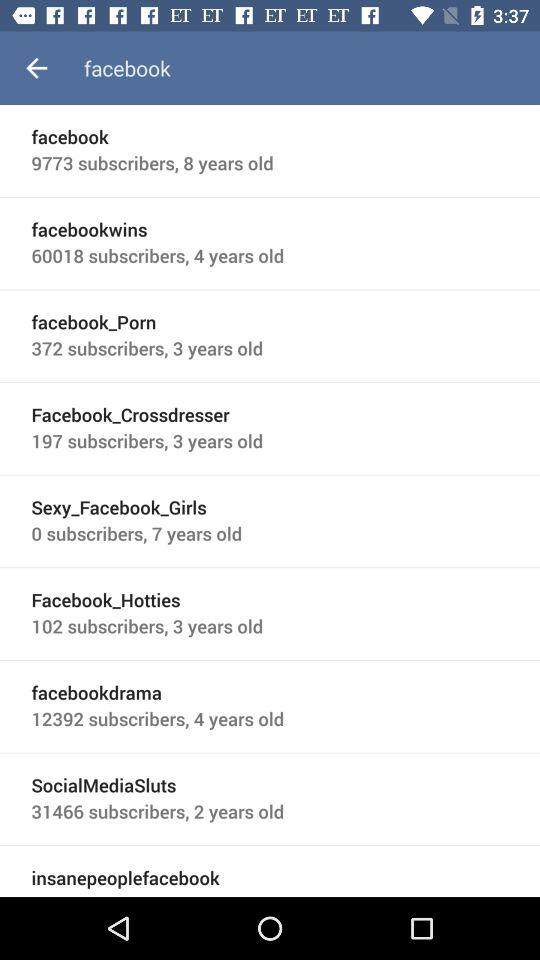What is the number of "facebook" subscribers? The number of "facebook" subscribers is 9773. 